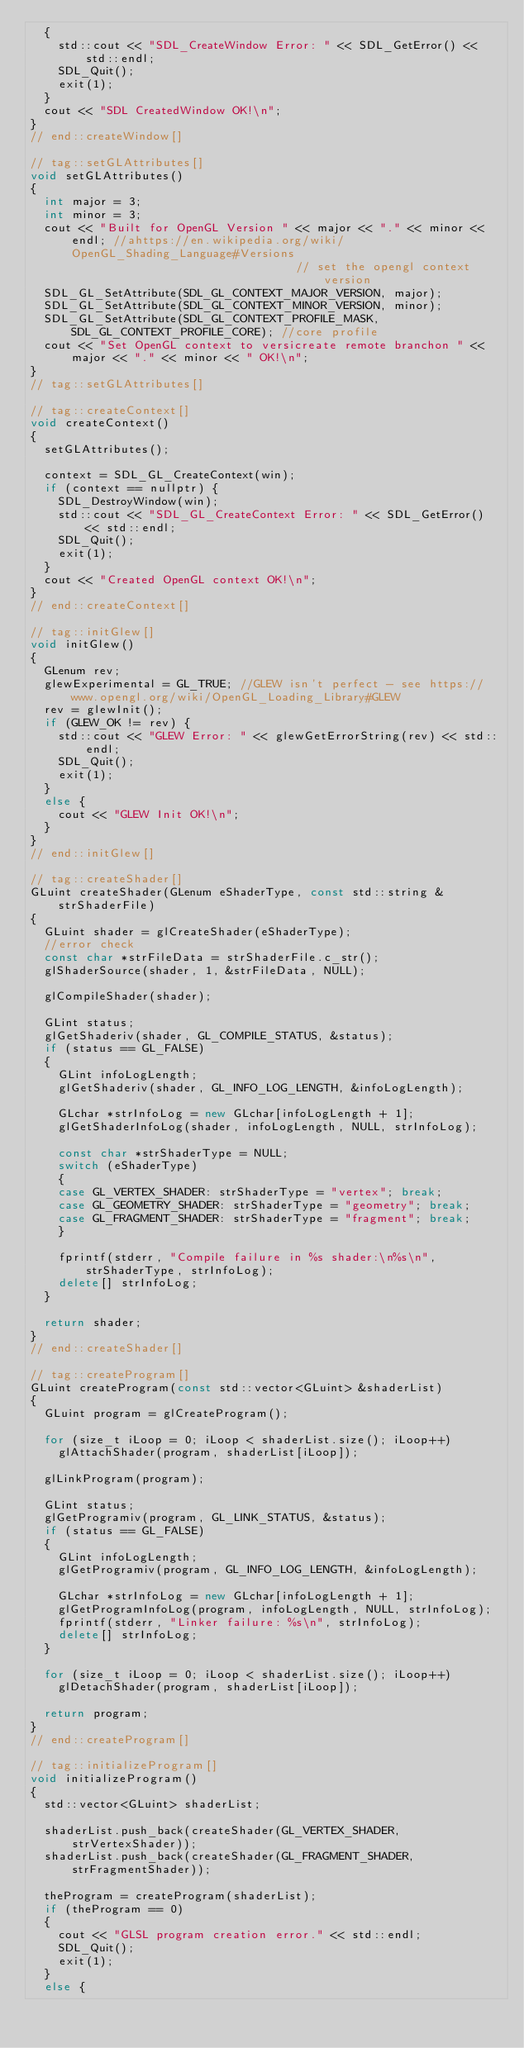<code> <loc_0><loc_0><loc_500><loc_500><_C++_>	{
		std::cout << "SDL_CreateWindow Error: " << SDL_GetError() << std::endl;
		SDL_Quit();
		exit(1);
	}
	cout << "SDL CreatedWindow OK!\n";
}
// end::createWindow[]

// tag::setGLAttributes[]
void setGLAttributes()
{
	int major = 3;
	int minor = 3;
	cout << "Built for OpenGL Version " << major << "." << minor << endl; //ahttps://en.wikipedia.org/wiki/OpenGL_Shading_Language#Versions
																		  // set the opengl context version
	SDL_GL_SetAttribute(SDL_GL_CONTEXT_MAJOR_VERSION, major);
	SDL_GL_SetAttribute(SDL_GL_CONTEXT_MINOR_VERSION, minor);
	SDL_GL_SetAttribute(SDL_GL_CONTEXT_PROFILE_MASK, SDL_GL_CONTEXT_PROFILE_CORE); //core profile
	cout << "Set OpenGL context to versicreate remote branchon " << major << "." << minor << " OK!\n";
}
// tag::setGLAttributes[]

// tag::createContext[]
void createContext()
{
	setGLAttributes();

	context = SDL_GL_CreateContext(win);
	if (context == nullptr) {
		SDL_DestroyWindow(win);
		std::cout << "SDL_GL_CreateContext Error: " << SDL_GetError() << std::endl;
		SDL_Quit();
		exit(1);
	}
	cout << "Created OpenGL context OK!\n";
}
// end::createContext[]

// tag::initGlew[]
void initGlew()
{
	GLenum rev;
	glewExperimental = GL_TRUE; //GLEW isn't perfect - see https://www.opengl.org/wiki/OpenGL_Loading_Library#GLEW
	rev = glewInit();
	if (GLEW_OK != rev) {
		std::cout << "GLEW Error: " << glewGetErrorString(rev) << std::endl;
		SDL_Quit();
		exit(1);
	}
	else {
		cout << "GLEW Init OK!\n";
	}
}
// end::initGlew[]

// tag::createShader[]
GLuint createShader(GLenum eShaderType, const std::string &strShaderFile)
{
	GLuint shader = glCreateShader(eShaderType);
	//error check
	const char *strFileData = strShaderFile.c_str();
	glShaderSource(shader, 1, &strFileData, NULL);

	glCompileShader(shader);

	GLint status;
	glGetShaderiv(shader, GL_COMPILE_STATUS, &status);
	if (status == GL_FALSE)
	{
		GLint infoLogLength;
		glGetShaderiv(shader, GL_INFO_LOG_LENGTH, &infoLogLength);

		GLchar *strInfoLog = new GLchar[infoLogLength + 1];
		glGetShaderInfoLog(shader, infoLogLength, NULL, strInfoLog);

		const char *strShaderType = NULL;
		switch (eShaderType)
		{
		case GL_VERTEX_SHADER: strShaderType = "vertex"; break;
		case GL_GEOMETRY_SHADER: strShaderType = "geometry"; break;
		case GL_FRAGMENT_SHADER: strShaderType = "fragment"; break;
		}

		fprintf(stderr, "Compile failure in %s shader:\n%s\n", strShaderType, strInfoLog);
		delete[] strInfoLog;
	}

	return shader;
}
// end::createShader[]

// tag::createProgram[]
GLuint createProgram(const std::vector<GLuint> &shaderList)
{
	GLuint program = glCreateProgram();

	for (size_t iLoop = 0; iLoop < shaderList.size(); iLoop++)
		glAttachShader(program, shaderList[iLoop]);

	glLinkProgram(program);

	GLint status;
	glGetProgramiv(program, GL_LINK_STATUS, &status);
	if (status == GL_FALSE)
	{
		GLint infoLogLength;
		glGetProgramiv(program, GL_INFO_LOG_LENGTH, &infoLogLength);

		GLchar *strInfoLog = new GLchar[infoLogLength + 1];
		glGetProgramInfoLog(program, infoLogLength, NULL, strInfoLog);
		fprintf(stderr, "Linker failure: %s\n", strInfoLog);
		delete[] strInfoLog;
	}

	for (size_t iLoop = 0; iLoop < shaderList.size(); iLoop++)
		glDetachShader(program, shaderList[iLoop]);

	return program;
}
// end::createProgram[]

// tag::initializeProgram[]
void initializeProgram()
{
	std::vector<GLuint> shaderList;

	shaderList.push_back(createShader(GL_VERTEX_SHADER, strVertexShader));
	shaderList.push_back(createShader(GL_FRAGMENT_SHADER, strFragmentShader));

	theProgram = createProgram(shaderList);
	if (theProgram == 0)
	{
		cout << "GLSL program creation error." << std::endl;
		SDL_Quit();
		exit(1);
	}
	else {</code> 